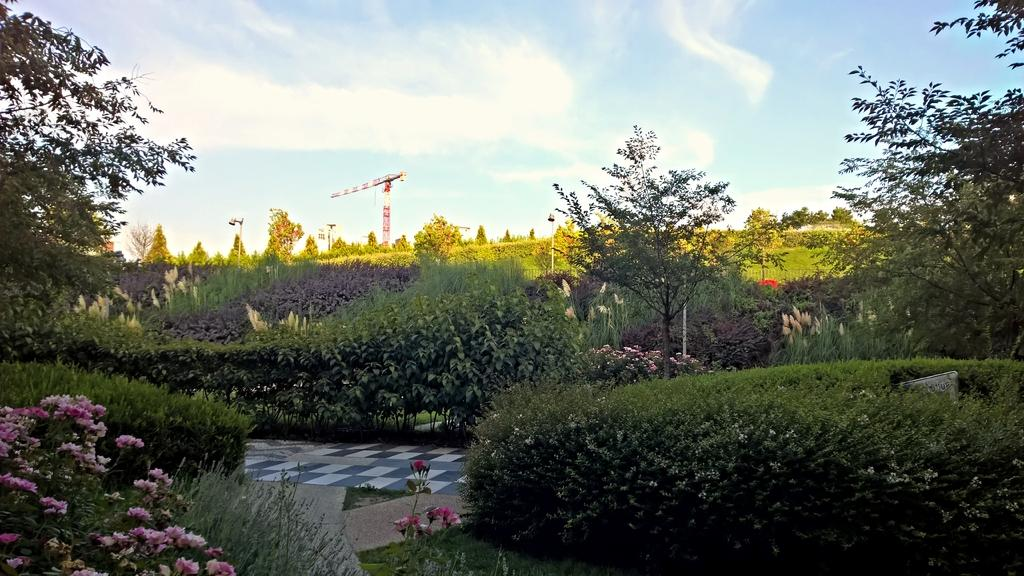What type of vegetation can be seen in the image? There are many plants and trees in the image. Are there any specific features of the plants? Yes, there are pink color flowers on the plants. What is visible in the background of the image? There is a pole in the background of the image. What can be seen in the sky? There are clouds in the sky, and the sky is blue. How many square cakes are placed on the twig in the image? There are no square cakes or twigs present in the image. 